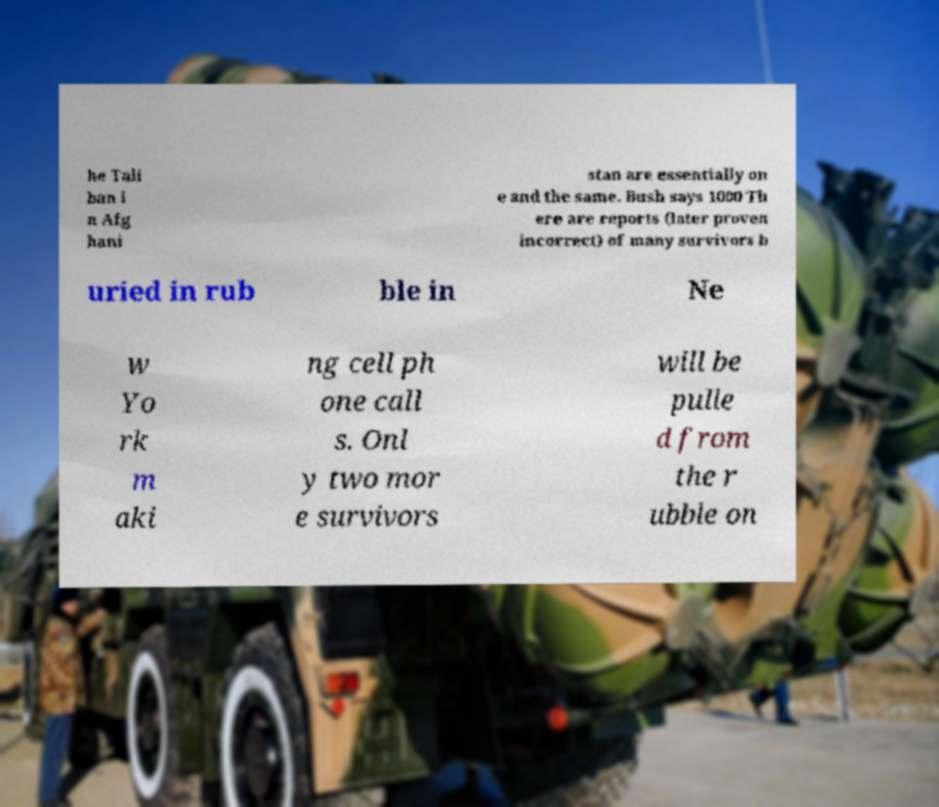Can you read and provide the text displayed in the image?This photo seems to have some interesting text. Can you extract and type it out for me? he Tali ban i n Afg hani stan are essentially on e and the same. Bush says 1000 Th ere are reports (later proven incorrect) of many survivors b uried in rub ble in Ne w Yo rk m aki ng cell ph one call s. Onl y two mor e survivors will be pulle d from the r ubble on 